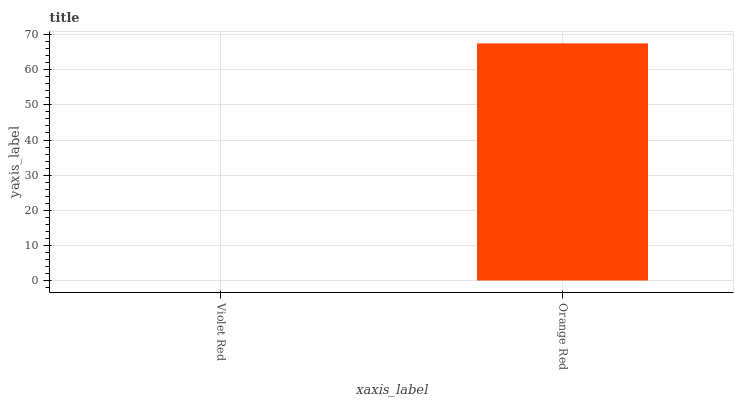Is Violet Red the minimum?
Answer yes or no. Yes. Is Orange Red the maximum?
Answer yes or no. Yes. Is Orange Red the minimum?
Answer yes or no. No. Is Orange Red greater than Violet Red?
Answer yes or no. Yes. Is Violet Red less than Orange Red?
Answer yes or no. Yes. Is Violet Red greater than Orange Red?
Answer yes or no. No. Is Orange Red less than Violet Red?
Answer yes or no. No. Is Orange Red the high median?
Answer yes or no. Yes. Is Violet Red the low median?
Answer yes or no. Yes. Is Violet Red the high median?
Answer yes or no. No. Is Orange Red the low median?
Answer yes or no. No. 